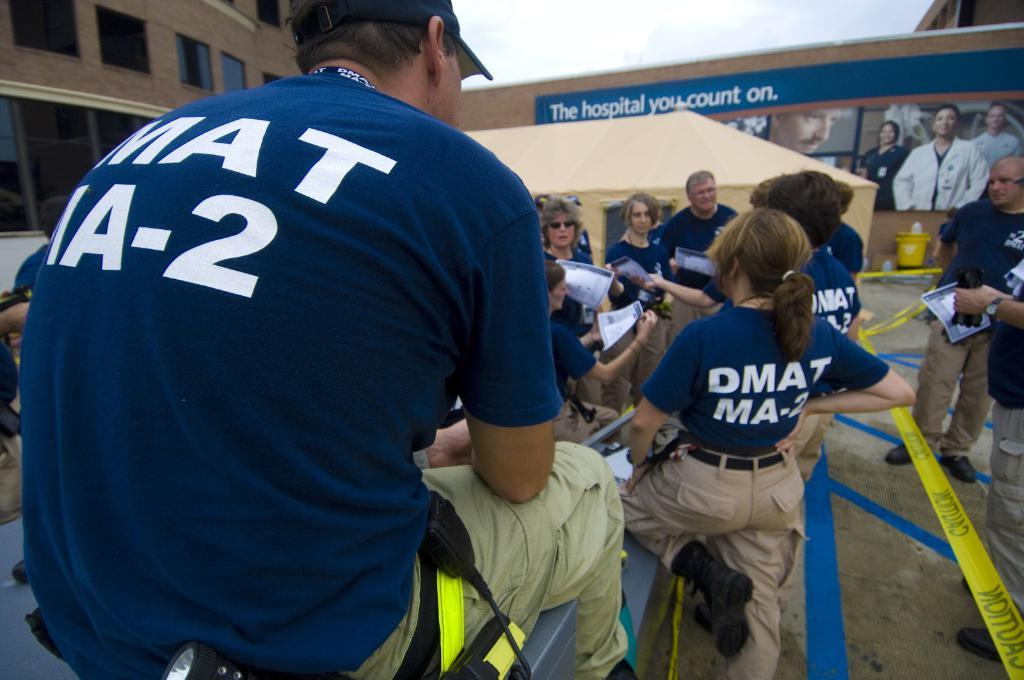<image>
Describe the image concisely. Group of people with navy shirt that has writing DMAT-2 on the back 